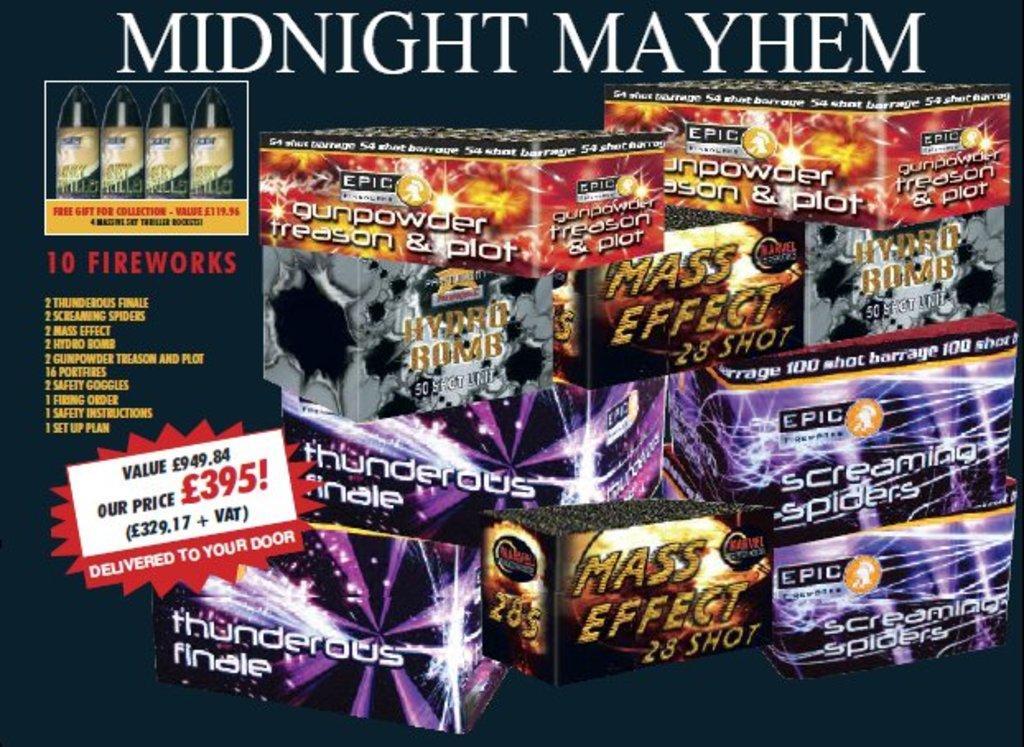When is this mayhem taking place?
Provide a succinct answer. Midnight. 